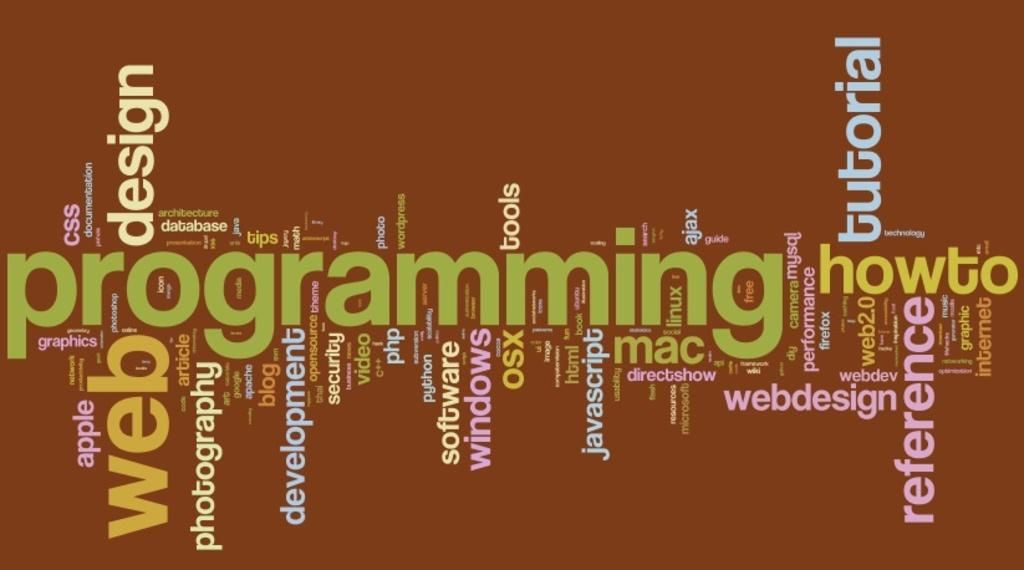<image>
Summarize the visual content of the image. A brown collage made out of computer related words such as web, software among others on a brown background. 